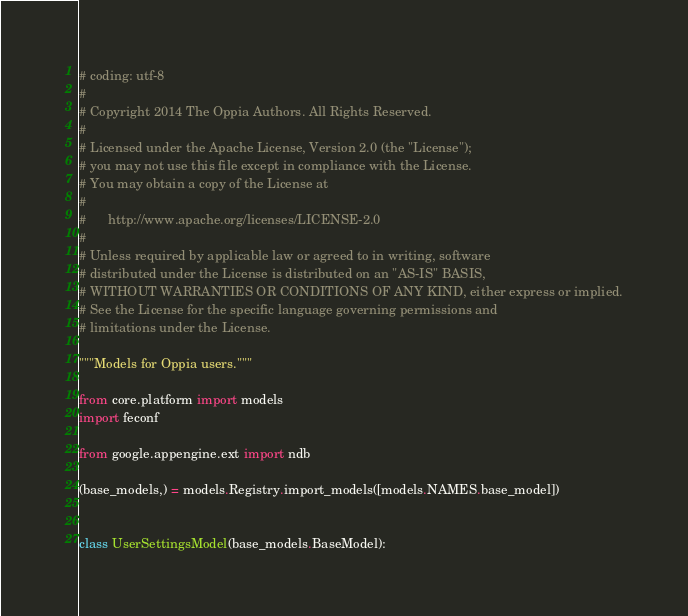<code> <loc_0><loc_0><loc_500><loc_500><_Python_># coding: utf-8
#
# Copyright 2014 The Oppia Authors. All Rights Reserved.
#
# Licensed under the Apache License, Version 2.0 (the "License");
# you may not use this file except in compliance with the License.
# You may obtain a copy of the License at
#
#      http://www.apache.org/licenses/LICENSE-2.0
#
# Unless required by applicable law or agreed to in writing, software
# distributed under the License is distributed on an "AS-IS" BASIS,
# WITHOUT WARRANTIES OR CONDITIONS OF ANY KIND, either express or implied.
# See the License for the specific language governing permissions and
# limitations under the License.

"""Models for Oppia users."""

from core.platform import models
import feconf

from google.appengine.ext import ndb

(base_models,) = models.Registry.import_models([models.NAMES.base_model])


class UserSettingsModel(base_models.BaseModel):</code> 